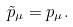Convert formula to latex. <formula><loc_0><loc_0><loc_500><loc_500>\tilde { p } _ { \mu } = p _ { \mu } .</formula> 